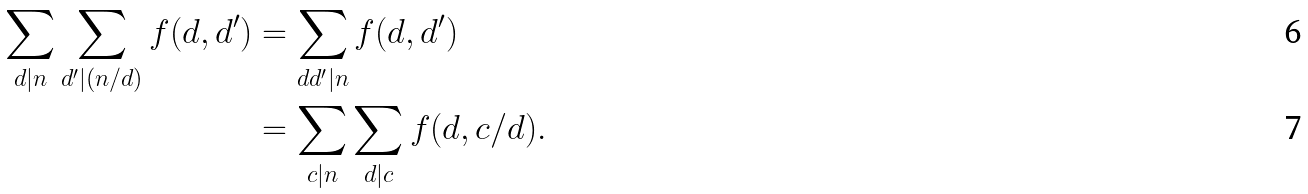<formula> <loc_0><loc_0><loc_500><loc_500>\sum _ { d | n } \sum _ { d ^ { \prime } | ( n / d ) } f ( d , d ^ { \prime } ) & = \sum _ { d d ^ { \prime } | n } f ( d , d ^ { \prime } ) \\ & = \sum _ { c | n } \sum _ { d | c } f ( d , c / d ) .</formula> 